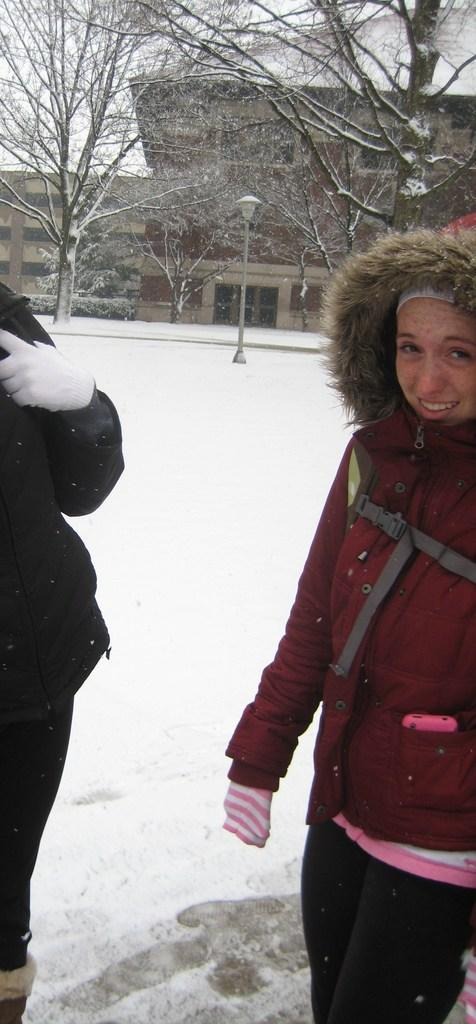How many people are in the image? There are two persons standing on the snow. What is the woman wearing? The woman is wearing a red coat and a cap. What can be seen in the background of the image? There is a group of trees and buildings in the background, as well as a pole. What type of jelly can be seen on the pole in the image? There is no jelly present in the image, and the pole does not have any jelly on it. 